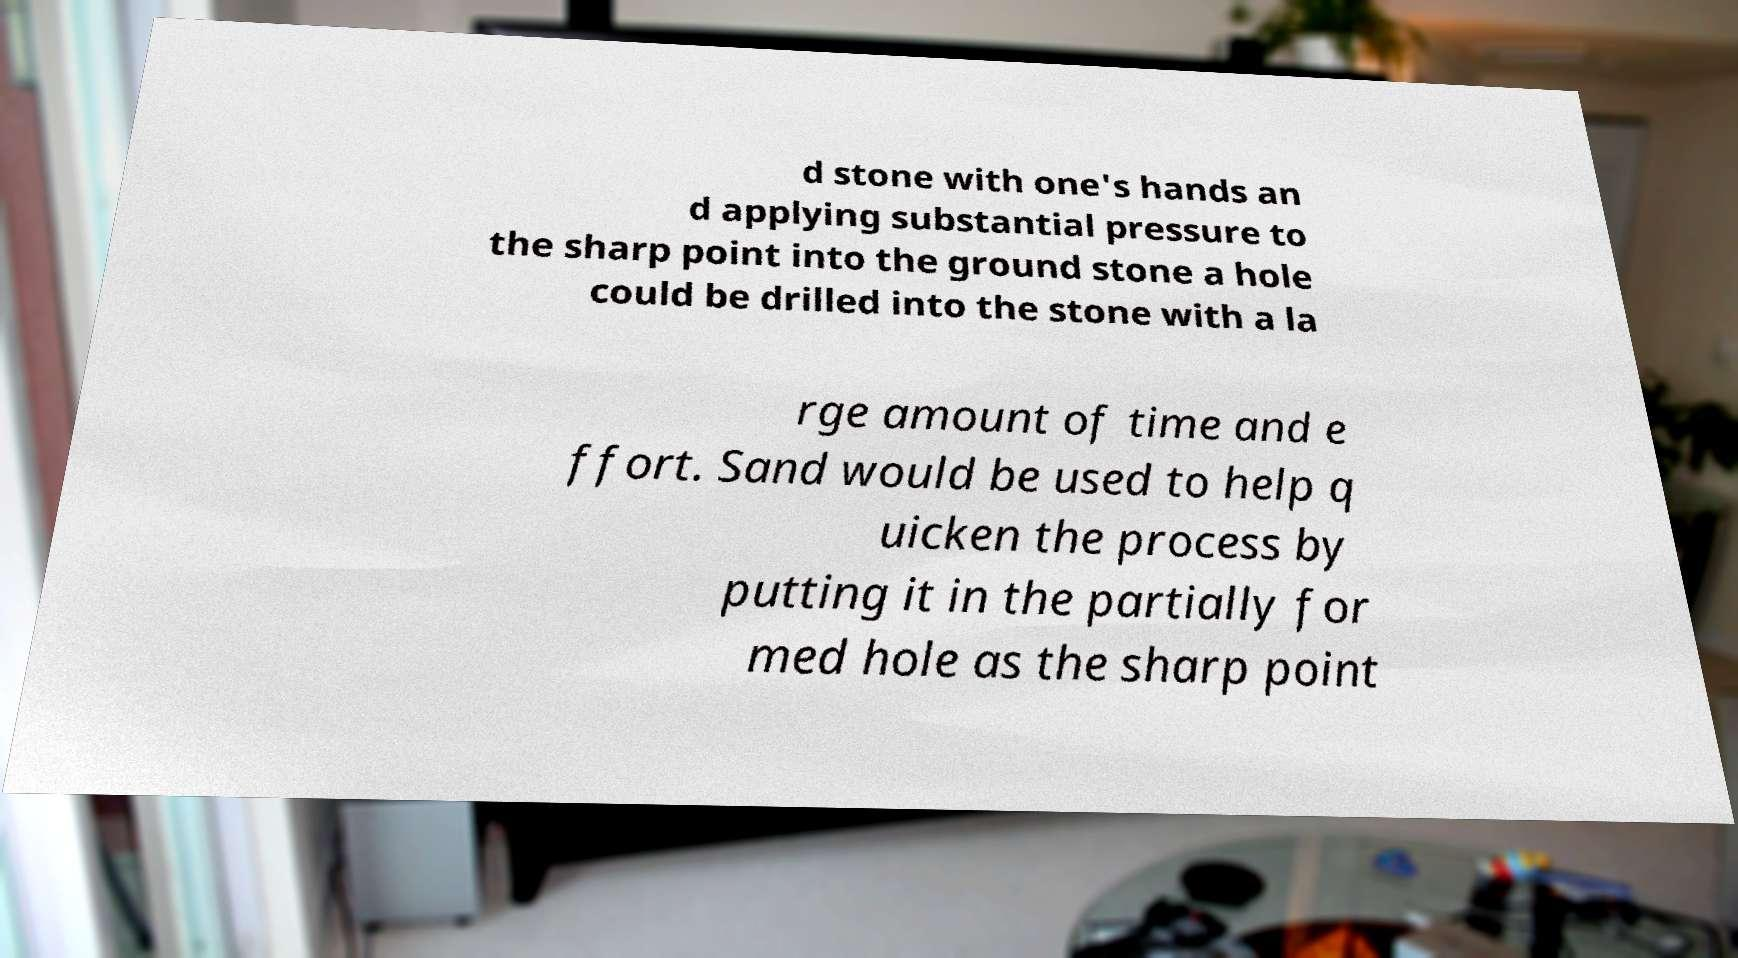Could you extract and type out the text from this image? d stone with one's hands an d applying substantial pressure to the sharp point into the ground stone a hole could be drilled into the stone with a la rge amount of time and e ffort. Sand would be used to help q uicken the process by putting it in the partially for med hole as the sharp point 